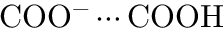Convert formula to latex. <formula><loc_0><loc_0><loc_500><loc_500>C O O ^ { - } \cdots C O O H</formula> 